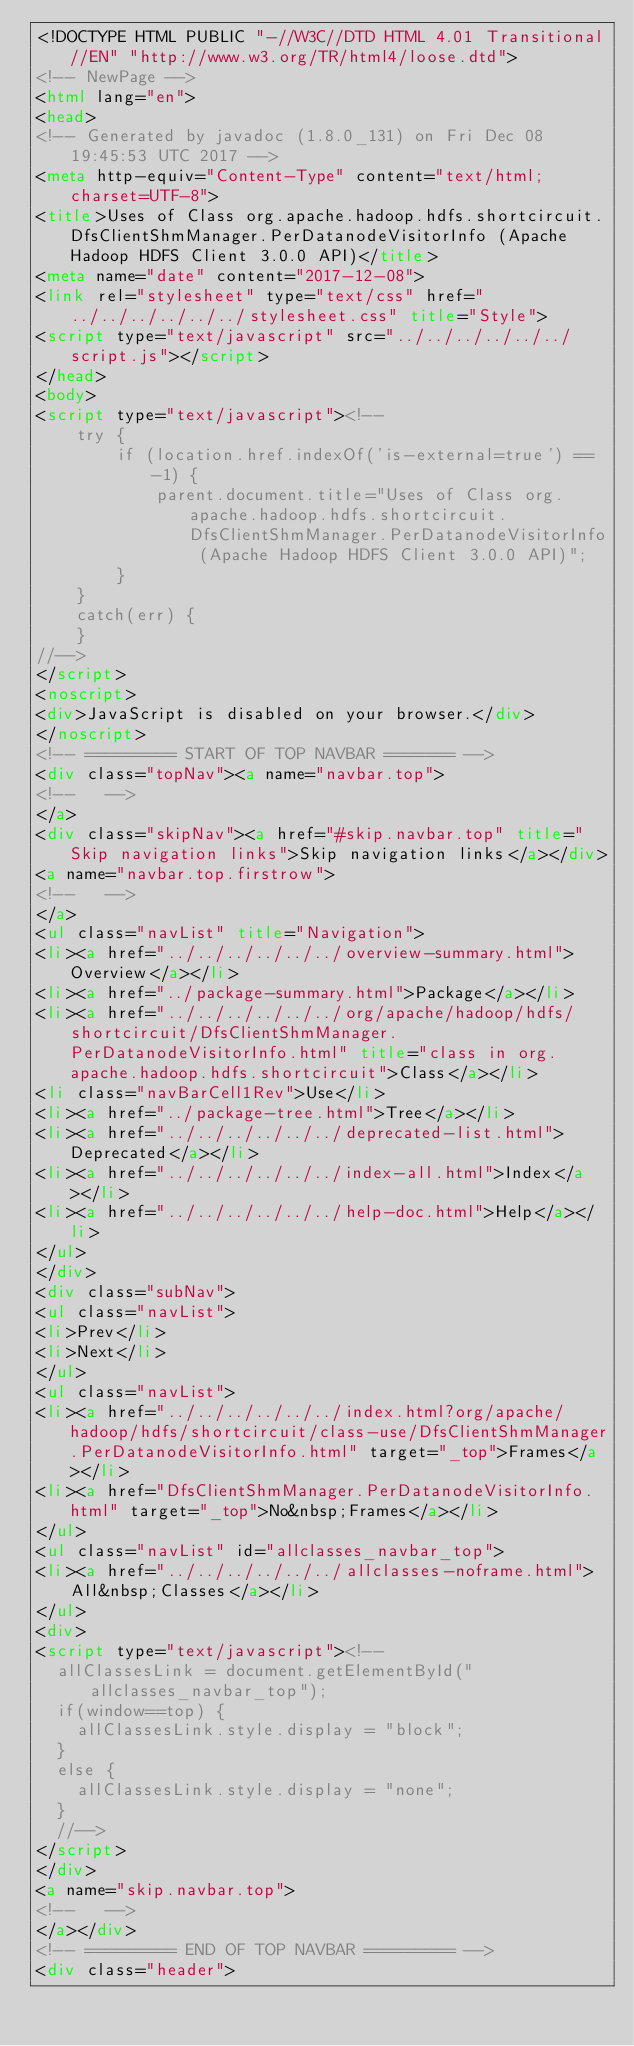Convert code to text. <code><loc_0><loc_0><loc_500><loc_500><_HTML_><!DOCTYPE HTML PUBLIC "-//W3C//DTD HTML 4.01 Transitional//EN" "http://www.w3.org/TR/html4/loose.dtd">
<!-- NewPage -->
<html lang="en">
<head>
<!-- Generated by javadoc (1.8.0_131) on Fri Dec 08 19:45:53 UTC 2017 -->
<meta http-equiv="Content-Type" content="text/html; charset=UTF-8">
<title>Uses of Class org.apache.hadoop.hdfs.shortcircuit.DfsClientShmManager.PerDatanodeVisitorInfo (Apache Hadoop HDFS Client 3.0.0 API)</title>
<meta name="date" content="2017-12-08">
<link rel="stylesheet" type="text/css" href="../../../../../../stylesheet.css" title="Style">
<script type="text/javascript" src="../../../../../../script.js"></script>
</head>
<body>
<script type="text/javascript"><!--
    try {
        if (location.href.indexOf('is-external=true') == -1) {
            parent.document.title="Uses of Class org.apache.hadoop.hdfs.shortcircuit.DfsClientShmManager.PerDatanodeVisitorInfo (Apache Hadoop HDFS Client 3.0.0 API)";
        }
    }
    catch(err) {
    }
//-->
</script>
<noscript>
<div>JavaScript is disabled on your browser.</div>
</noscript>
<!-- ========= START OF TOP NAVBAR ======= -->
<div class="topNav"><a name="navbar.top">
<!--   -->
</a>
<div class="skipNav"><a href="#skip.navbar.top" title="Skip navigation links">Skip navigation links</a></div>
<a name="navbar.top.firstrow">
<!--   -->
</a>
<ul class="navList" title="Navigation">
<li><a href="../../../../../../overview-summary.html">Overview</a></li>
<li><a href="../package-summary.html">Package</a></li>
<li><a href="../../../../../../org/apache/hadoop/hdfs/shortcircuit/DfsClientShmManager.PerDatanodeVisitorInfo.html" title="class in org.apache.hadoop.hdfs.shortcircuit">Class</a></li>
<li class="navBarCell1Rev">Use</li>
<li><a href="../package-tree.html">Tree</a></li>
<li><a href="../../../../../../deprecated-list.html">Deprecated</a></li>
<li><a href="../../../../../../index-all.html">Index</a></li>
<li><a href="../../../../../../help-doc.html">Help</a></li>
</ul>
</div>
<div class="subNav">
<ul class="navList">
<li>Prev</li>
<li>Next</li>
</ul>
<ul class="navList">
<li><a href="../../../../../../index.html?org/apache/hadoop/hdfs/shortcircuit/class-use/DfsClientShmManager.PerDatanodeVisitorInfo.html" target="_top">Frames</a></li>
<li><a href="DfsClientShmManager.PerDatanodeVisitorInfo.html" target="_top">No&nbsp;Frames</a></li>
</ul>
<ul class="navList" id="allclasses_navbar_top">
<li><a href="../../../../../../allclasses-noframe.html">All&nbsp;Classes</a></li>
</ul>
<div>
<script type="text/javascript"><!--
  allClassesLink = document.getElementById("allclasses_navbar_top");
  if(window==top) {
    allClassesLink.style.display = "block";
  }
  else {
    allClassesLink.style.display = "none";
  }
  //-->
</script>
</div>
<a name="skip.navbar.top">
<!--   -->
</a></div>
<!-- ========= END OF TOP NAVBAR ========= -->
<div class="header"></code> 